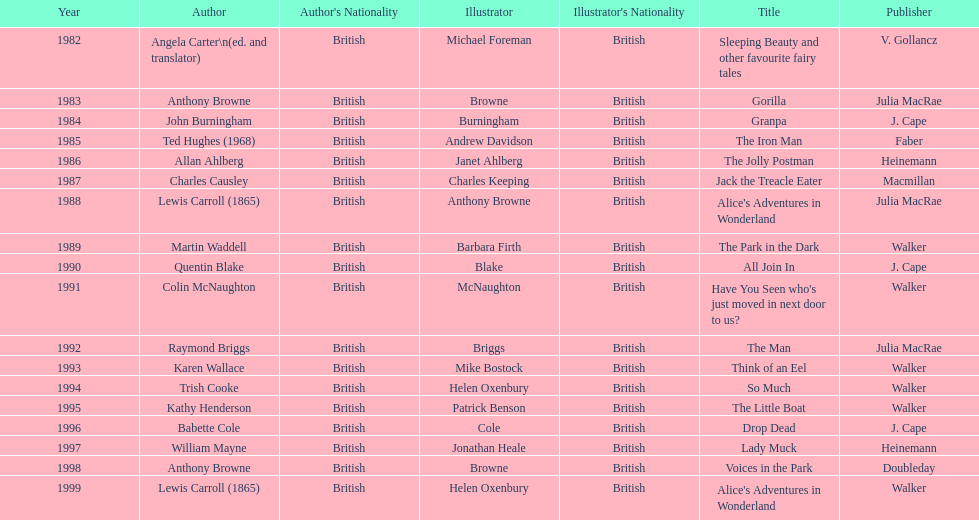How many times has anthony browne won an kurt maschler award for illustration? 3. 